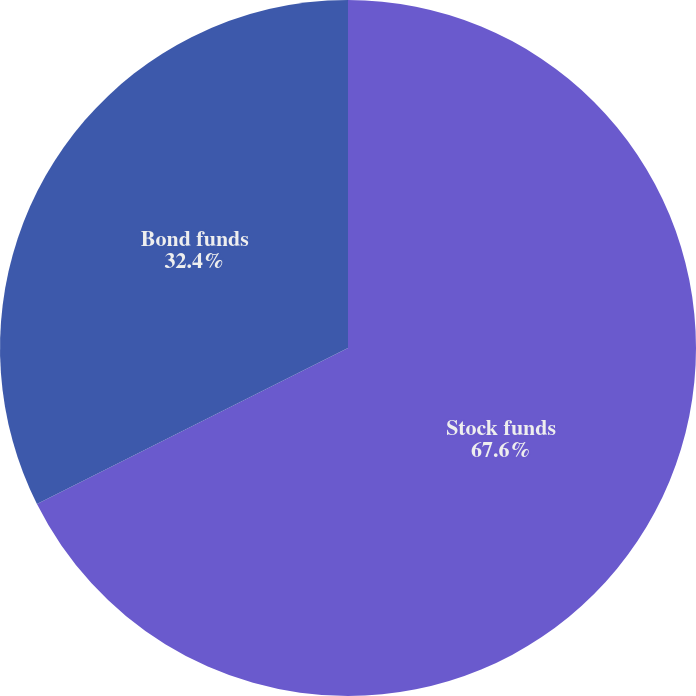<chart> <loc_0><loc_0><loc_500><loc_500><pie_chart><fcel>Stock funds<fcel>Bond funds<nl><fcel>67.6%<fcel>32.4%<nl></chart> 